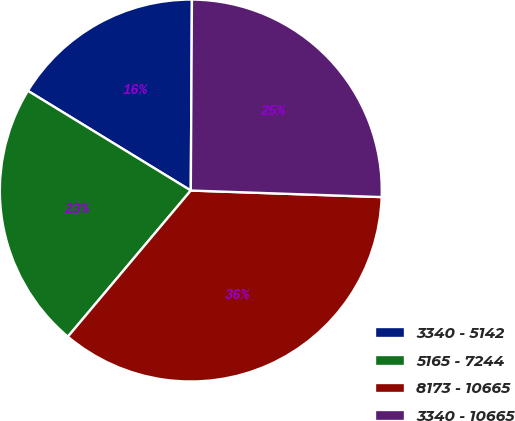<chart> <loc_0><loc_0><loc_500><loc_500><pie_chart><fcel>3340 - 5142<fcel>5165 - 7244<fcel>8173 - 10665<fcel>3340 - 10665<nl><fcel>16.35%<fcel>22.61%<fcel>35.58%<fcel>25.45%<nl></chart> 